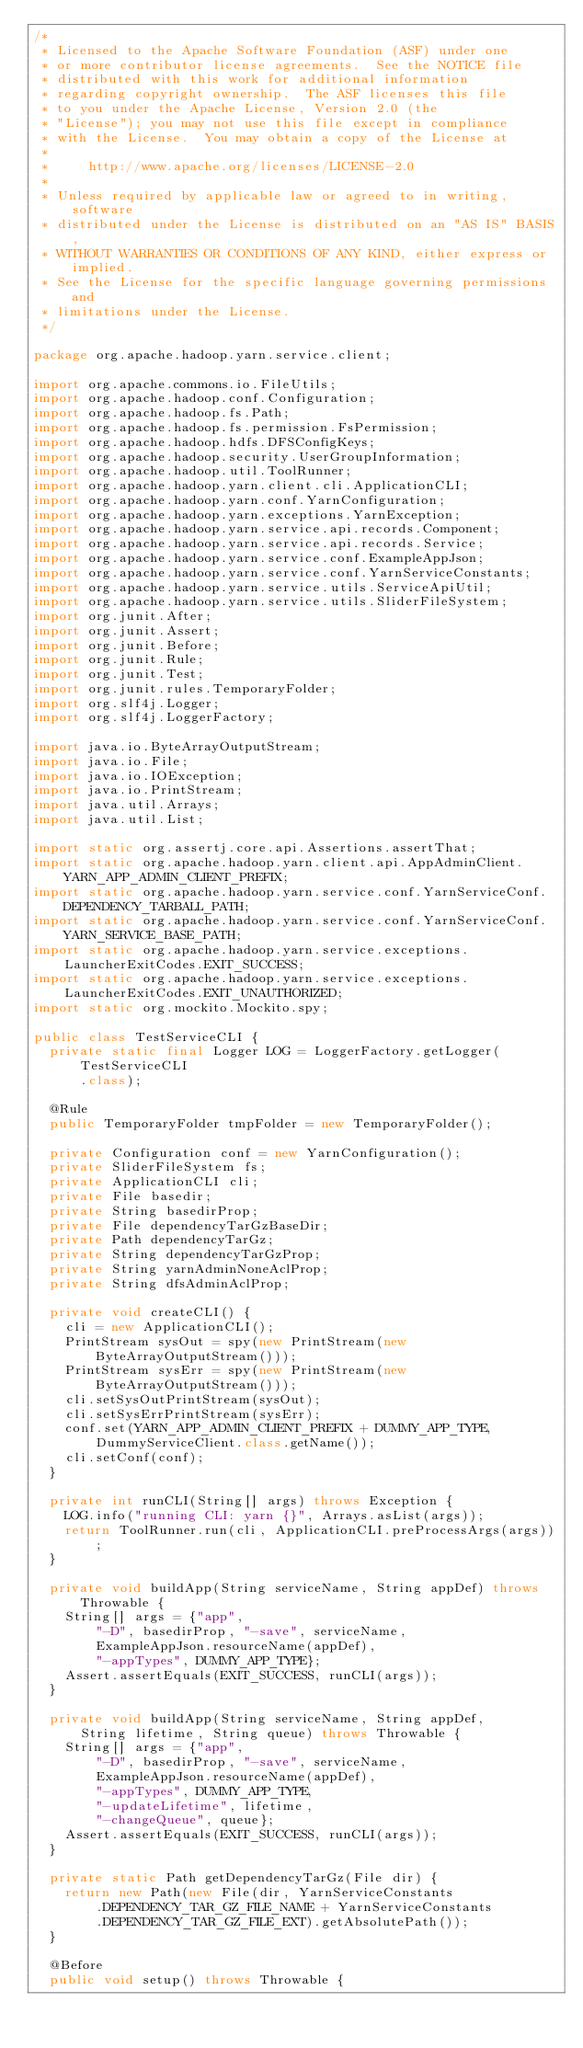<code> <loc_0><loc_0><loc_500><loc_500><_Java_>/*
 * Licensed to the Apache Software Foundation (ASF) under one
 * or more contributor license agreements.  See the NOTICE file
 * distributed with this work for additional information
 * regarding copyright ownership.  The ASF licenses this file
 * to you under the Apache License, Version 2.0 (the
 * "License"); you may not use this file except in compliance
 * with the License.  You may obtain a copy of the License at
 *
 *     http://www.apache.org/licenses/LICENSE-2.0
 *
 * Unless required by applicable law or agreed to in writing, software
 * distributed under the License is distributed on an "AS IS" BASIS,
 * WITHOUT WARRANTIES OR CONDITIONS OF ANY KIND, either express or implied.
 * See the License for the specific language governing permissions and
 * limitations under the License.
 */

package org.apache.hadoop.yarn.service.client;

import org.apache.commons.io.FileUtils;
import org.apache.hadoop.conf.Configuration;
import org.apache.hadoop.fs.Path;
import org.apache.hadoop.fs.permission.FsPermission;
import org.apache.hadoop.hdfs.DFSConfigKeys;
import org.apache.hadoop.security.UserGroupInformation;
import org.apache.hadoop.util.ToolRunner;
import org.apache.hadoop.yarn.client.cli.ApplicationCLI;
import org.apache.hadoop.yarn.conf.YarnConfiguration;
import org.apache.hadoop.yarn.exceptions.YarnException;
import org.apache.hadoop.yarn.service.api.records.Component;
import org.apache.hadoop.yarn.service.api.records.Service;
import org.apache.hadoop.yarn.service.conf.ExampleAppJson;
import org.apache.hadoop.yarn.service.conf.YarnServiceConstants;
import org.apache.hadoop.yarn.service.utils.ServiceApiUtil;
import org.apache.hadoop.yarn.service.utils.SliderFileSystem;
import org.junit.After;
import org.junit.Assert;
import org.junit.Before;
import org.junit.Rule;
import org.junit.Test;
import org.junit.rules.TemporaryFolder;
import org.slf4j.Logger;
import org.slf4j.LoggerFactory;

import java.io.ByteArrayOutputStream;
import java.io.File;
import java.io.IOException;
import java.io.PrintStream;
import java.util.Arrays;
import java.util.List;

import static org.assertj.core.api.Assertions.assertThat;
import static org.apache.hadoop.yarn.client.api.AppAdminClient.YARN_APP_ADMIN_CLIENT_PREFIX;
import static org.apache.hadoop.yarn.service.conf.YarnServiceConf.DEPENDENCY_TARBALL_PATH;
import static org.apache.hadoop.yarn.service.conf.YarnServiceConf.YARN_SERVICE_BASE_PATH;
import static org.apache.hadoop.yarn.service.exceptions.LauncherExitCodes.EXIT_SUCCESS;
import static org.apache.hadoop.yarn.service.exceptions.LauncherExitCodes.EXIT_UNAUTHORIZED;
import static org.mockito.Mockito.spy;

public class TestServiceCLI {
  private static final Logger LOG = LoggerFactory.getLogger(TestServiceCLI
      .class);

  @Rule
  public TemporaryFolder tmpFolder = new TemporaryFolder();

  private Configuration conf = new YarnConfiguration();
  private SliderFileSystem fs;
  private ApplicationCLI cli;
  private File basedir;
  private String basedirProp;
  private File dependencyTarGzBaseDir;
  private Path dependencyTarGz;
  private String dependencyTarGzProp;
  private String yarnAdminNoneAclProp;
  private String dfsAdminAclProp;

  private void createCLI() {
    cli = new ApplicationCLI();
    PrintStream sysOut = spy(new PrintStream(new ByteArrayOutputStream()));
    PrintStream sysErr = spy(new PrintStream(new ByteArrayOutputStream()));
    cli.setSysOutPrintStream(sysOut);
    cli.setSysErrPrintStream(sysErr);
    conf.set(YARN_APP_ADMIN_CLIENT_PREFIX + DUMMY_APP_TYPE,
        DummyServiceClient.class.getName());
    cli.setConf(conf);
  }

  private int runCLI(String[] args) throws Exception {
    LOG.info("running CLI: yarn {}", Arrays.asList(args));
    return ToolRunner.run(cli, ApplicationCLI.preProcessArgs(args));
  }

  private void buildApp(String serviceName, String appDef) throws Throwable {
    String[] args = {"app",
        "-D", basedirProp, "-save", serviceName,
        ExampleAppJson.resourceName(appDef),
        "-appTypes", DUMMY_APP_TYPE};
    Assert.assertEquals(EXIT_SUCCESS, runCLI(args));
  }

  private void buildApp(String serviceName, String appDef,
      String lifetime, String queue) throws Throwable {
    String[] args = {"app",
        "-D", basedirProp, "-save", serviceName,
        ExampleAppJson.resourceName(appDef),
        "-appTypes", DUMMY_APP_TYPE,
        "-updateLifetime", lifetime,
        "-changeQueue", queue};
    Assert.assertEquals(EXIT_SUCCESS, runCLI(args));
  }

  private static Path getDependencyTarGz(File dir) {
    return new Path(new File(dir, YarnServiceConstants
        .DEPENDENCY_TAR_GZ_FILE_NAME + YarnServiceConstants
        .DEPENDENCY_TAR_GZ_FILE_EXT).getAbsolutePath());
  }

  @Before
  public void setup() throws Throwable {</code> 